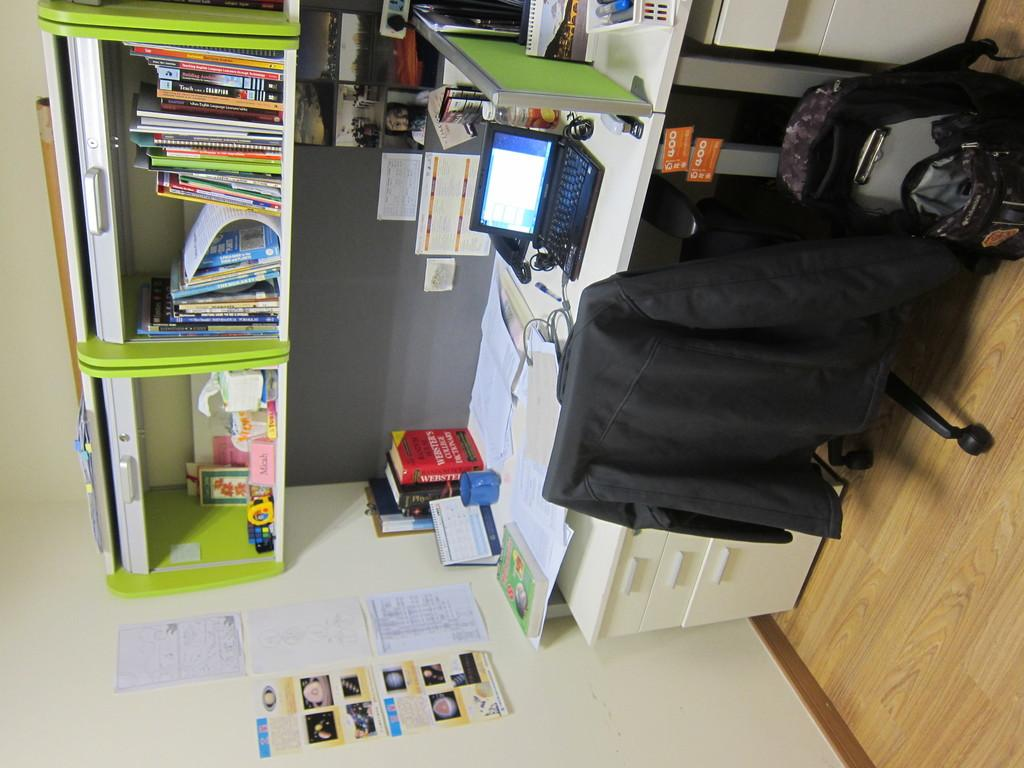Provide a one-sentence caption for the provided image. A sideways image of a person's desk shows a laptop and a Websters College Dictionary among many other items. 